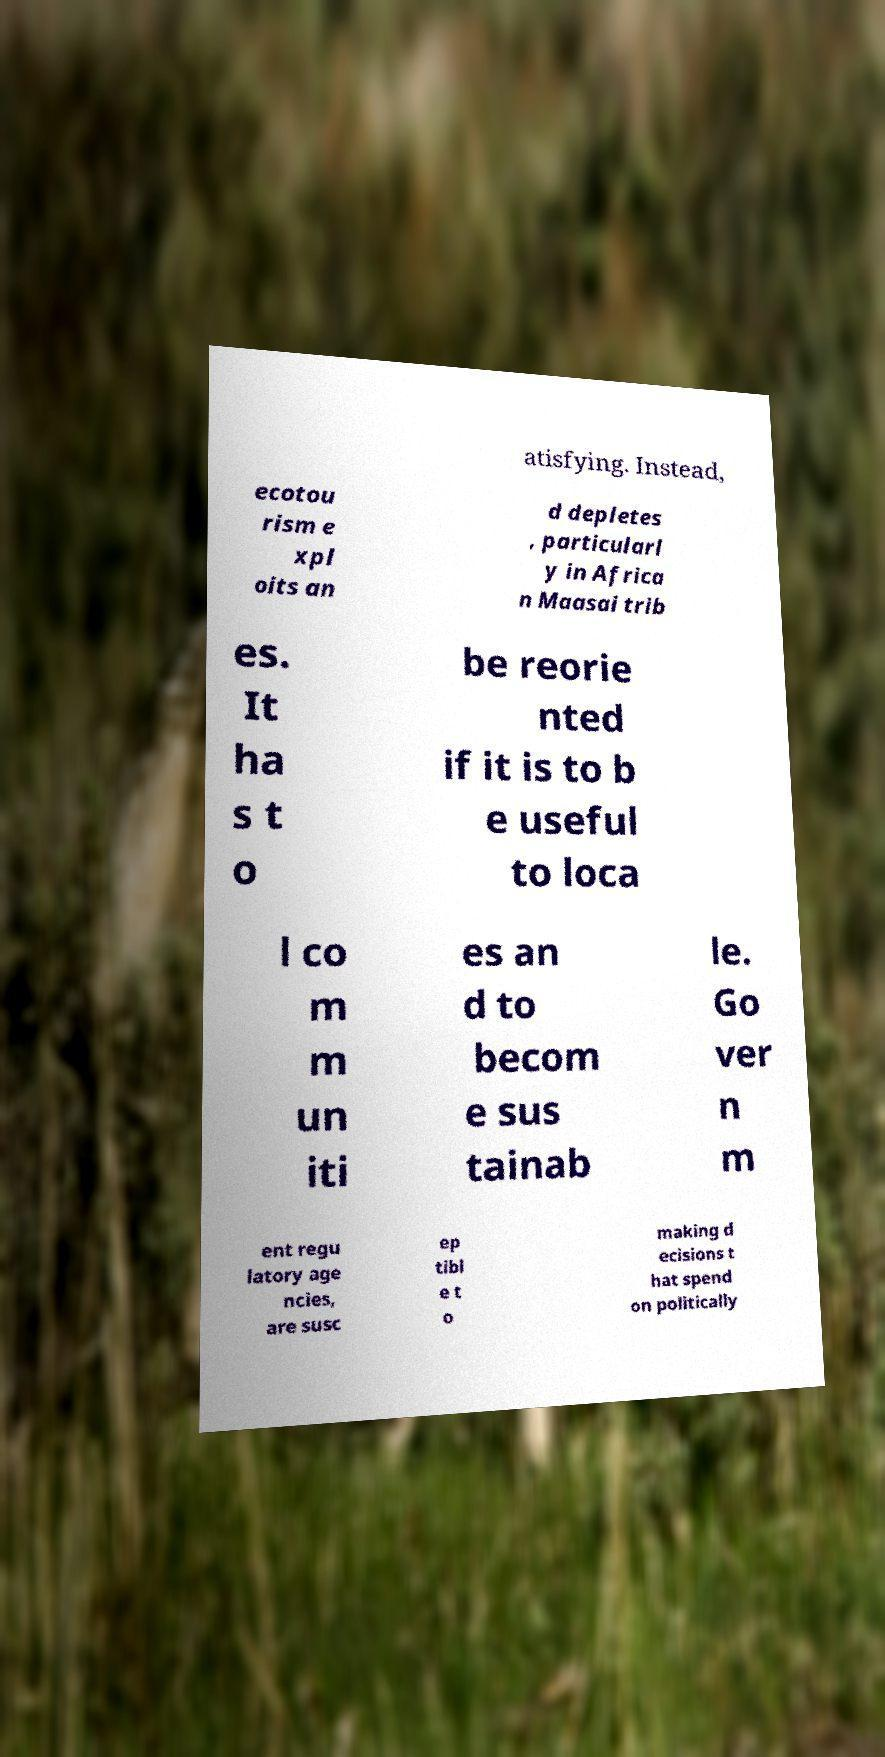Can you accurately transcribe the text from the provided image for me? atisfying. Instead, ecotou rism e xpl oits an d depletes , particularl y in Africa n Maasai trib es. It ha s t o be reorie nted if it is to b e useful to loca l co m m un iti es an d to becom e sus tainab le. Go ver n m ent regu latory age ncies, are susc ep tibl e t o making d ecisions t hat spend on politically 